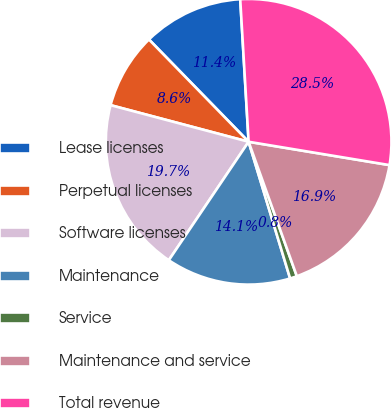<chart> <loc_0><loc_0><loc_500><loc_500><pie_chart><fcel>Lease licenses<fcel>Perpetual licenses<fcel>Software licenses<fcel>Maintenance<fcel>Service<fcel>Maintenance and service<fcel>Total revenue<nl><fcel>11.36%<fcel>8.58%<fcel>19.69%<fcel>14.13%<fcel>0.79%<fcel>16.91%<fcel>28.55%<nl></chart> 